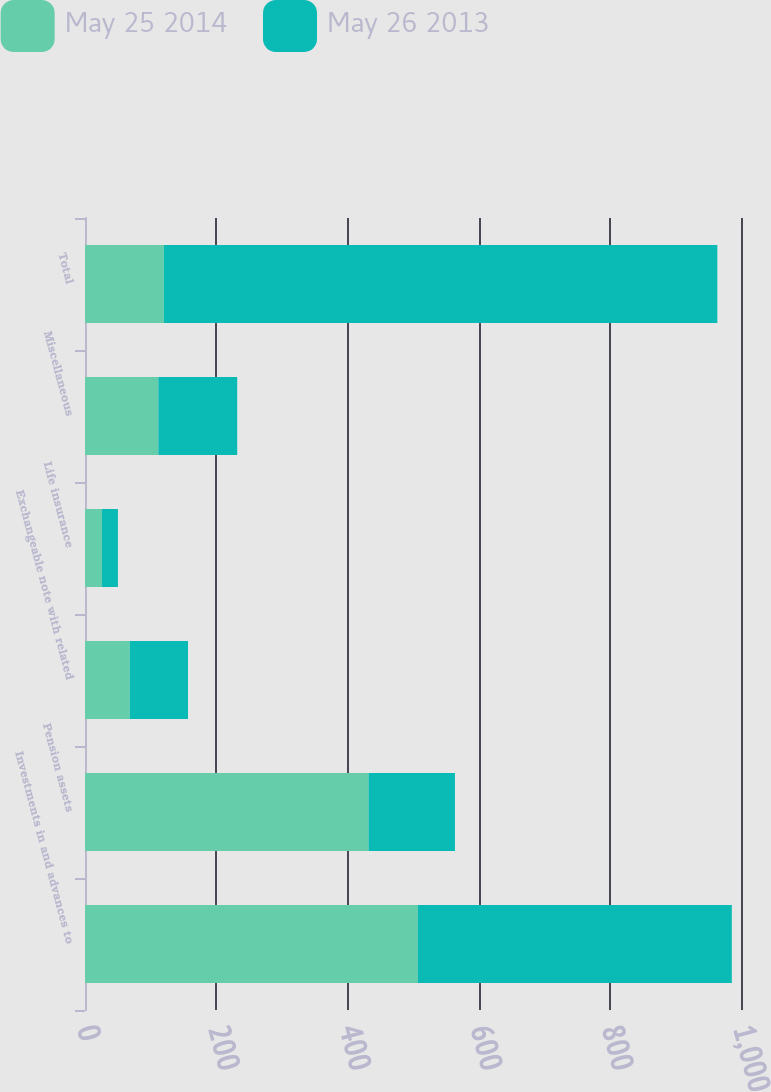<chart> <loc_0><loc_0><loc_500><loc_500><stacked_bar_chart><ecel><fcel>Investments in and advances to<fcel>Pension assets<fcel>Exchangeable note with related<fcel>Life insurance<fcel>Miscellaneous<fcel>Total<nl><fcel>May 25 2014<fcel>507.5<fcel>432.2<fcel>68.2<fcel>25.8<fcel>111.8<fcel>120.2<nl><fcel>May 26 2013<fcel>478.5<fcel>131.8<fcel>88.8<fcel>24.4<fcel>120.2<fcel>843.7<nl></chart> 